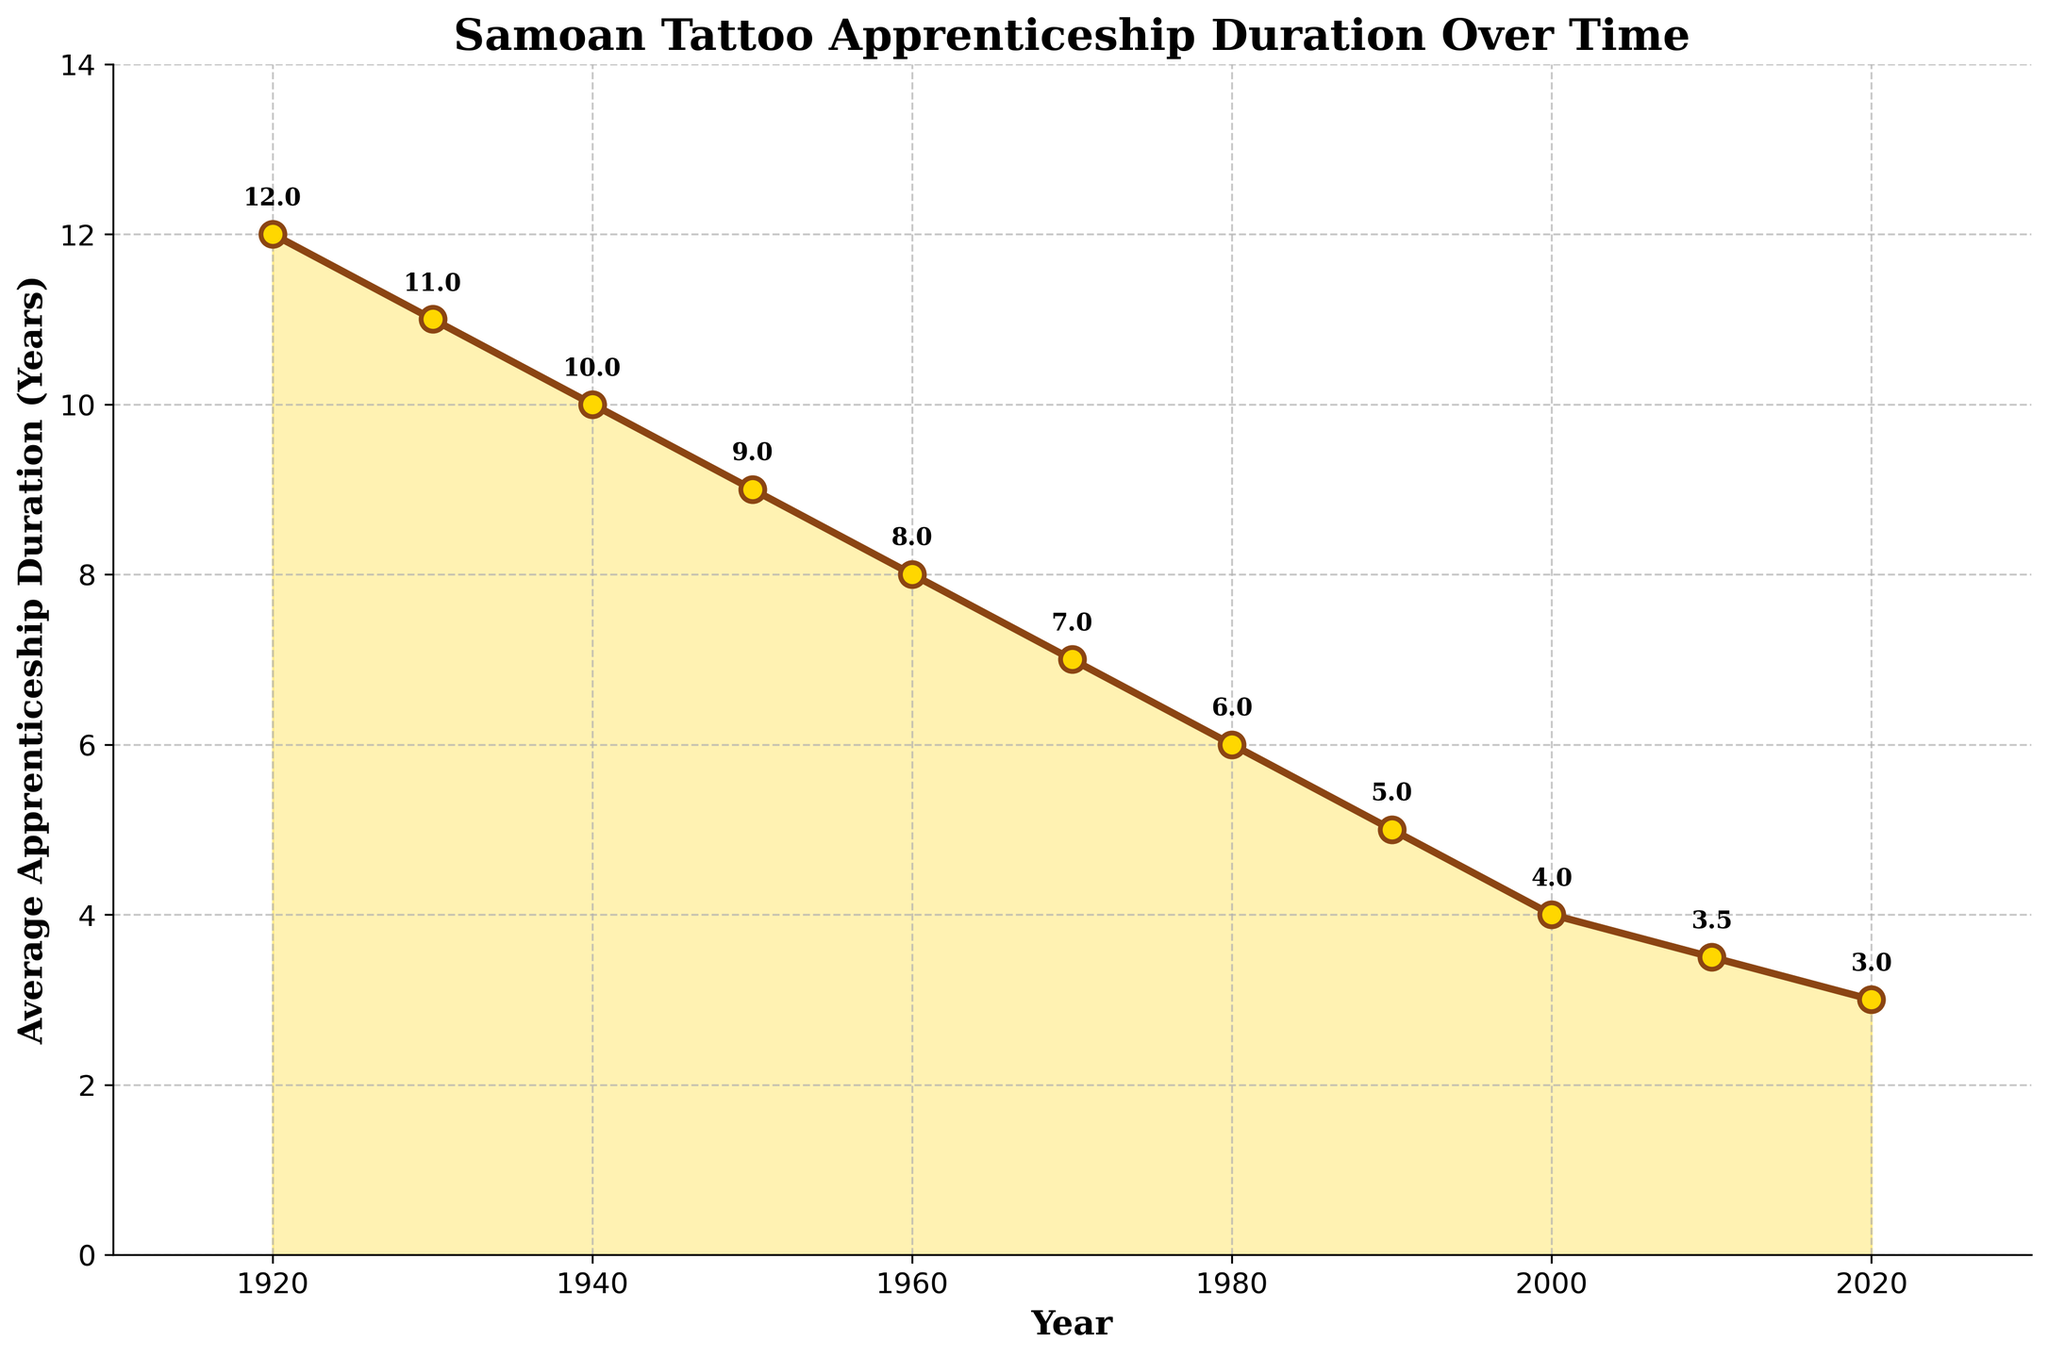What's the general trend in apprenticeship duration over the century? The figure shows that the average apprenticeship duration has gradually decreased over time from 12 years in 1920 to 3 years in 2020.
Answer: It's decreasing In which decade did the steepest decline in average apprenticeship duration occur? By comparing the slopes of the line segments in the plot, the steepest decline is between 1990 and 2000, where the duration drops from 5 years to 4 years.
Answer: 1990-2000 What is the difference in years between the longest and shortest apprenticeship durations? The longest duration is 12 years (1920) and the shortest is 3 years (2020). The difference is calculated as 12 - 3 = 9 years.
Answer: 9 years Which year marks the first time the average apprenticeship duration drops below 10 years? According to the plot annotations, in 1940 the average dropped to 10 years, thus 1950 is the first year it went below 10 years with an average of 9 years.
Answer: 1950 How much shorter is the apprenticeship duration in 2020 compared to 1960? The apprenticeship duration in 2020 is 3 years and in 1960 it was 8 years, so the difference is 8 - 3 = 5 years.
Answer: 5 years What visual element is used to fill the area under the line plot? The area under the plot line is filled with a light golden-yellow color.
Answer: Light golden-yellow color By how many years did the apprenticeship duration decrease between 1980 and 2000? The duration in 1980 was 6 years and in 2000 it was 4 years, so the difference is 6 - 4 = 2 years.
Answer: 2 years What is the average apprenticeship duration between 1920 and 1950? By summing the durations (12 + 11 + 10 + 9) and dividing by the number of years (4), the average duration is (12 + 11 + 10 + 9) / 4 = 10.5 years.
Answer: 10.5 years Which year had an average apprenticeship duration closest to 5 years? The figure shows that the year 1990 had an average apprenticeship duration of exactly 5 years.
Answer: 1990 Comparing 1950 and 2010, which year had the shorter apprenticeship duration and by how much? In 1950, the duration was 9 years, and in 2010 it was 3.5 years. The duration is shorter in 2010 by 9 - 3.5 = 5.5 years.
Answer: 2010 by 5.5 years 